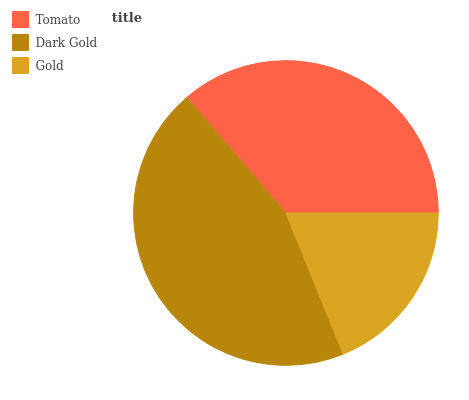Is Gold the minimum?
Answer yes or no. Yes. Is Dark Gold the maximum?
Answer yes or no. Yes. Is Dark Gold the minimum?
Answer yes or no. No. Is Gold the maximum?
Answer yes or no. No. Is Dark Gold greater than Gold?
Answer yes or no. Yes. Is Gold less than Dark Gold?
Answer yes or no. Yes. Is Gold greater than Dark Gold?
Answer yes or no. No. Is Dark Gold less than Gold?
Answer yes or no. No. Is Tomato the high median?
Answer yes or no. Yes. Is Tomato the low median?
Answer yes or no. Yes. Is Dark Gold the high median?
Answer yes or no. No. Is Dark Gold the low median?
Answer yes or no. No. 